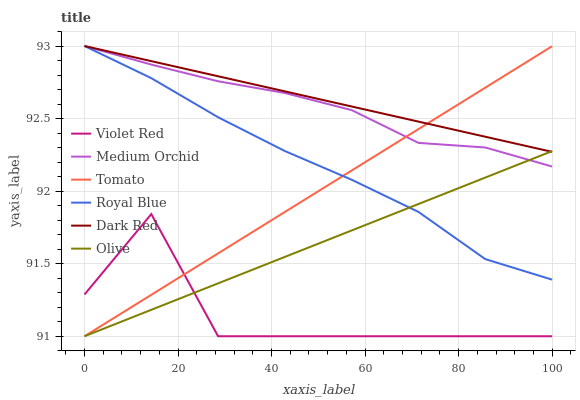Does Violet Red have the minimum area under the curve?
Answer yes or no. Yes. Does Dark Red have the maximum area under the curve?
Answer yes or no. Yes. Does Dark Red have the minimum area under the curve?
Answer yes or no. No. Does Violet Red have the maximum area under the curve?
Answer yes or no. No. Is Tomato the smoothest?
Answer yes or no. Yes. Is Violet Red the roughest?
Answer yes or no. Yes. Is Dark Red the smoothest?
Answer yes or no. No. Is Dark Red the roughest?
Answer yes or no. No. Does Tomato have the lowest value?
Answer yes or no. Yes. Does Dark Red have the lowest value?
Answer yes or no. No. Does Royal Blue have the highest value?
Answer yes or no. Yes. Does Violet Red have the highest value?
Answer yes or no. No. Is Violet Red less than Royal Blue?
Answer yes or no. Yes. Is Royal Blue greater than Violet Red?
Answer yes or no. Yes. Does Dark Red intersect Royal Blue?
Answer yes or no. Yes. Is Dark Red less than Royal Blue?
Answer yes or no. No. Is Dark Red greater than Royal Blue?
Answer yes or no. No. Does Violet Red intersect Royal Blue?
Answer yes or no. No. 